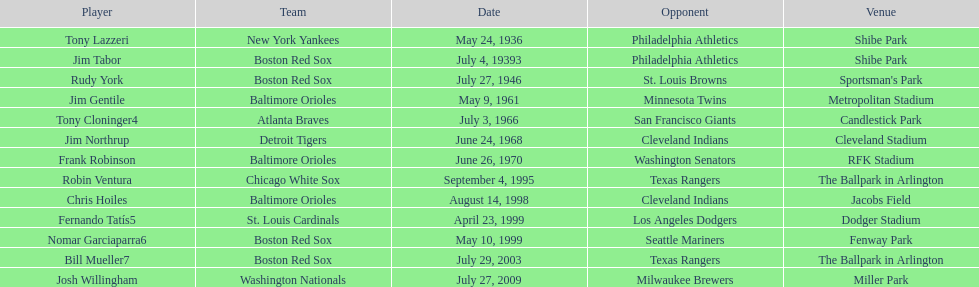What is the number of times a boston red sox player has had two grand slams in one game? 4. 